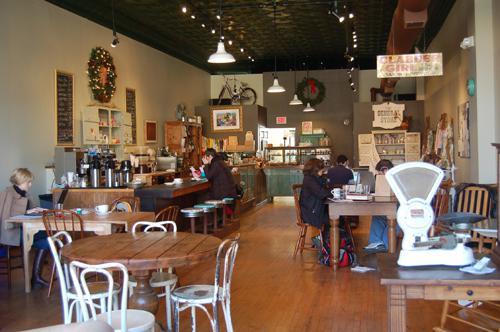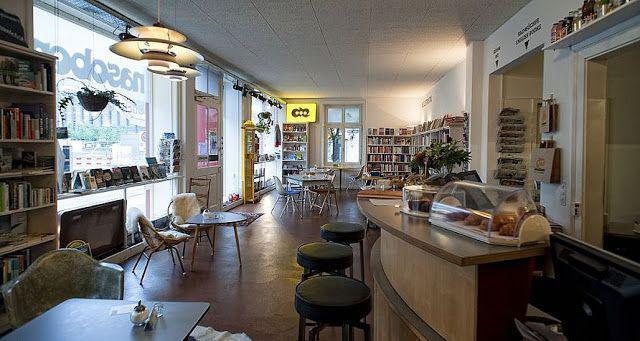The first image is the image on the left, the second image is the image on the right. Assess this claim about the two images: "There are stools at the bar.". Correct or not? Answer yes or no. Yes. The first image is the image on the left, the second image is the image on the right. Assess this claim about the two images: "Both images in the pair show a cafe where coffee or pastries are served.". Correct or not? Answer yes or no. Yes. 